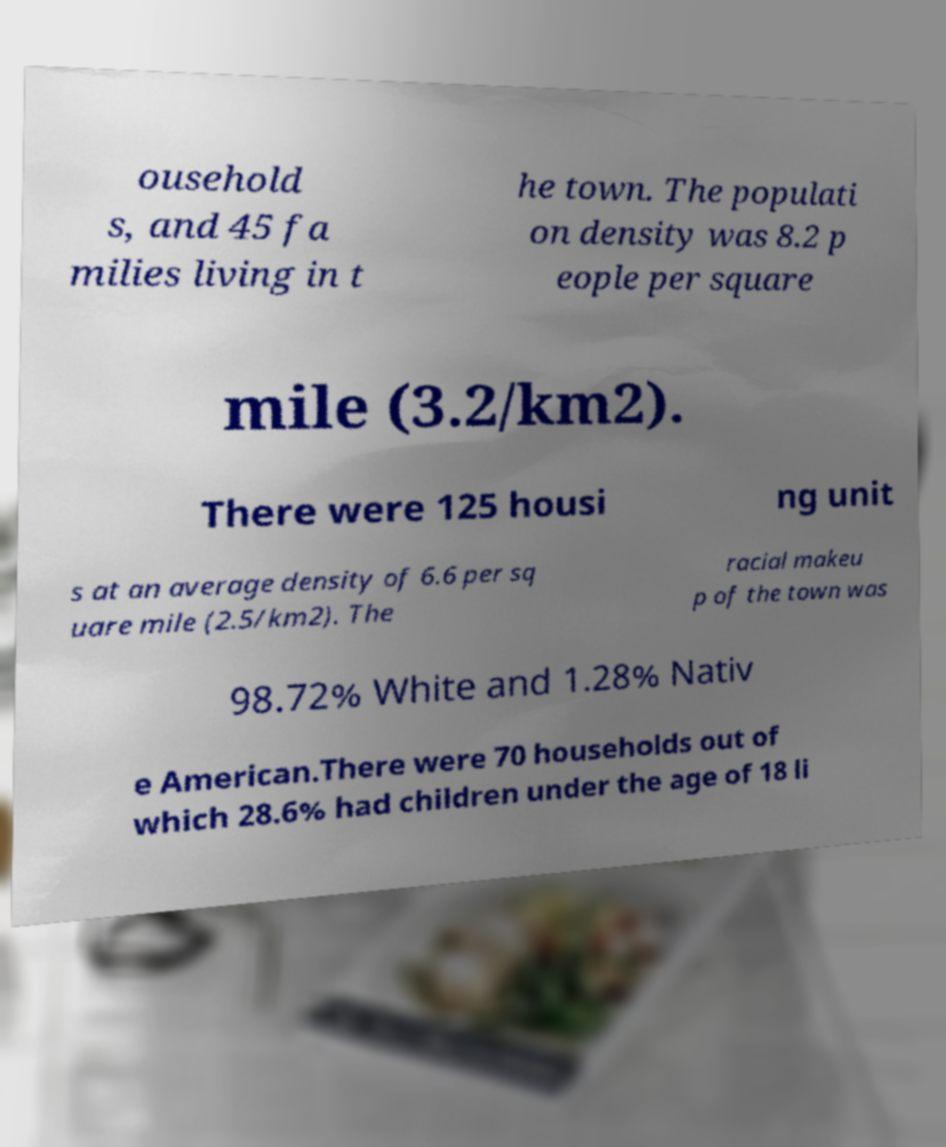Please read and relay the text visible in this image. What does it say? ousehold s, and 45 fa milies living in t he town. The populati on density was 8.2 p eople per square mile (3.2/km2). There were 125 housi ng unit s at an average density of 6.6 per sq uare mile (2.5/km2). The racial makeu p of the town was 98.72% White and 1.28% Nativ e American.There were 70 households out of which 28.6% had children under the age of 18 li 